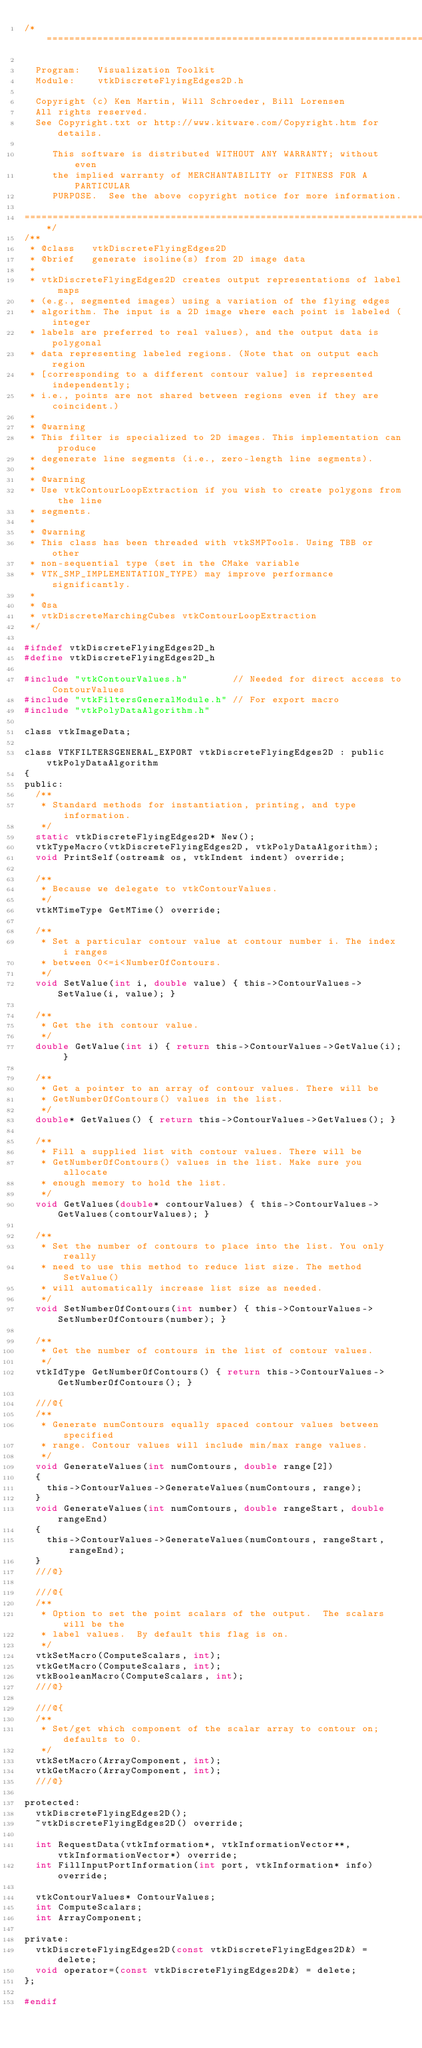<code> <loc_0><loc_0><loc_500><loc_500><_C_>/*=========================================================================

  Program:   Visualization Toolkit
  Module:    vtkDiscreteFlyingEdges2D.h

  Copyright (c) Ken Martin, Will Schroeder, Bill Lorensen
  All rights reserved.
  See Copyright.txt or http://www.kitware.com/Copyright.htm for details.

     This software is distributed WITHOUT ANY WARRANTY; without even
     the implied warranty of MERCHANTABILITY or FITNESS FOR A PARTICULAR
     PURPOSE.  See the above copyright notice for more information.

=========================================================================*/
/**
 * @class   vtkDiscreteFlyingEdges2D
 * @brief   generate isoline(s) from 2D image data
 *
 * vtkDiscreteFlyingEdges2D creates output representations of label maps
 * (e.g., segmented images) using a variation of the flying edges
 * algorithm. The input is a 2D image where each point is labeled (integer
 * labels are preferred to real values), and the output data is polygonal
 * data representing labeled regions. (Note that on output each region
 * [corresponding to a different contour value] is represented independently;
 * i.e., points are not shared between regions even if they are coincident.)
 *
 * @warning
 * This filter is specialized to 2D images. This implementation can produce
 * degenerate line segments (i.e., zero-length line segments).
 *
 * @warning
 * Use vtkContourLoopExtraction if you wish to create polygons from the line
 * segments.
 *
 * @warning
 * This class has been threaded with vtkSMPTools. Using TBB or other
 * non-sequential type (set in the CMake variable
 * VTK_SMP_IMPLEMENTATION_TYPE) may improve performance significantly.
 *
 * @sa
 * vtkDiscreteMarchingCubes vtkContourLoopExtraction
 */

#ifndef vtkDiscreteFlyingEdges2D_h
#define vtkDiscreteFlyingEdges2D_h

#include "vtkContourValues.h"        // Needed for direct access to ContourValues
#include "vtkFiltersGeneralModule.h" // For export macro
#include "vtkPolyDataAlgorithm.h"

class vtkImageData;

class VTKFILTERSGENERAL_EXPORT vtkDiscreteFlyingEdges2D : public vtkPolyDataAlgorithm
{
public:
  /**
   * Standard methods for instantiation, printing, and type information.
   */
  static vtkDiscreteFlyingEdges2D* New();
  vtkTypeMacro(vtkDiscreteFlyingEdges2D, vtkPolyDataAlgorithm);
  void PrintSelf(ostream& os, vtkIndent indent) override;

  /**
   * Because we delegate to vtkContourValues.
   */
  vtkMTimeType GetMTime() override;

  /**
   * Set a particular contour value at contour number i. The index i ranges
   * between 0<=i<NumberOfContours.
   */
  void SetValue(int i, double value) { this->ContourValues->SetValue(i, value); }

  /**
   * Get the ith contour value.
   */
  double GetValue(int i) { return this->ContourValues->GetValue(i); }

  /**
   * Get a pointer to an array of contour values. There will be
   * GetNumberOfContours() values in the list.
   */
  double* GetValues() { return this->ContourValues->GetValues(); }

  /**
   * Fill a supplied list with contour values. There will be
   * GetNumberOfContours() values in the list. Make sure you allocate
   * enough memory to hold the list.
   */
  void GetValues(double* contourValues) { this->ContourValues->GetValues(contourValues); }

  /**
   * Set the number of contours to place into the list. You only really
   * need to use this method to reduce list size. The method SetValue()
   * will automatically increase list size as needed.
   */
  void SetNumberOfContours(int number) { this->ContourValues->SetNumberOfContours(number); }

  /**
   * Get the number of contours in the list of contour values.
   */
  vtkIdType GetNumberOfContours() { return this->ContourValues->GetNumberOfContours(); }

  ///@{
  /**
   * Generate numContours equally spaced contour values between specified
   * range. Contour values will include min/max range values.
   */
  void GenerateValues(int numContours, double range[2])
  {
    this->ContourValues->GenerateValues(numContours, range);
  }
  void GenerateValues(int numContours, double rangeStart, double rangeEnd)
  {
    this->ContourValues->GenerateValues(numContours, rangeStart, rangeEnd);
  }
  ///@}

  ///@{
  /**
   * Option to set the point scalars of the output.  The scalars will be the
   * label values.  By default this flag is on.
   */
  vtkSetMacro(ComputeScalars, int);
  vtkGetMacro(ComputeScalars, int);
  vtkBooleanMacro(ComputeScalars, int);
  ///@}

  ///@{
  /**
   * Set/get which component of the scalar array to contour on; defaults to 0.
   */
  vtkSetMacro(ArrayComponent, int);
  vtkGetMacro(ArrayComponent, int);
  ///@}

protected:
  vtkDiscreteFlyingEdges2D();
  ~vtkDiscreteFlyingEdges2D() override;

  int RequestData(vtkInformation*, vtkInformationVector**, vtkInformationVector*) override;
  int FillInputPortInformation(int port, vtkInformation* info) override;

  vtkContourValues* ContourValues;
  int ComputeScalars;
  int ArrayComponent;

private:
  vtkDiscreteFlyingEdges2D(const vtkDiscreteFlyingEdges2D&) = delete;
  void operator=(const vtkDiscreteFlyingEdges2D&) = delete;
};

#endif
</code> 